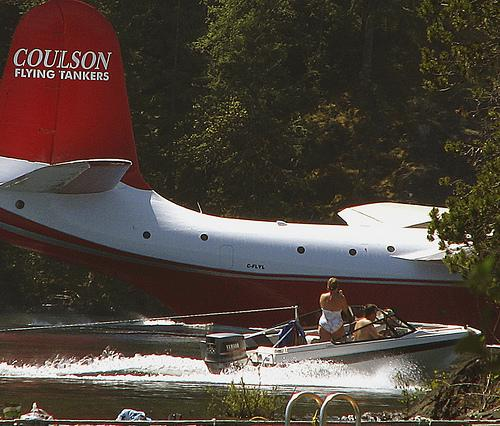Based on the circumstances of the image what method of transportation currently moves the fastest? boat 